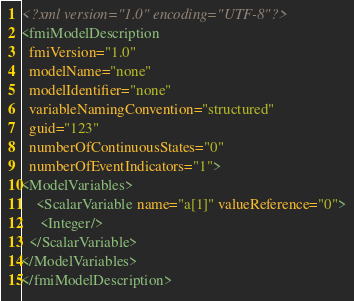<code> <loc_0><loc_0><loc_500><loc_500><_XML_><?xml version="1.0" encoding="UTF-8"?>
<fmiModelDescription
  fmiVersion="1.0"
  modelName="none"
  modelIdentifier="none"
  variableNamingConvention="structured"
  guid="123"
  numberOfContinuousStates="0"
  numberOfEventIndicators="1">
<ModelVariables>
    <ScalarVariable name="a[1]" valueReference="0">
     <Integer/>
  </ScalarVariable>
</ModelVariables>
</fmiModelDescription>

</code> 